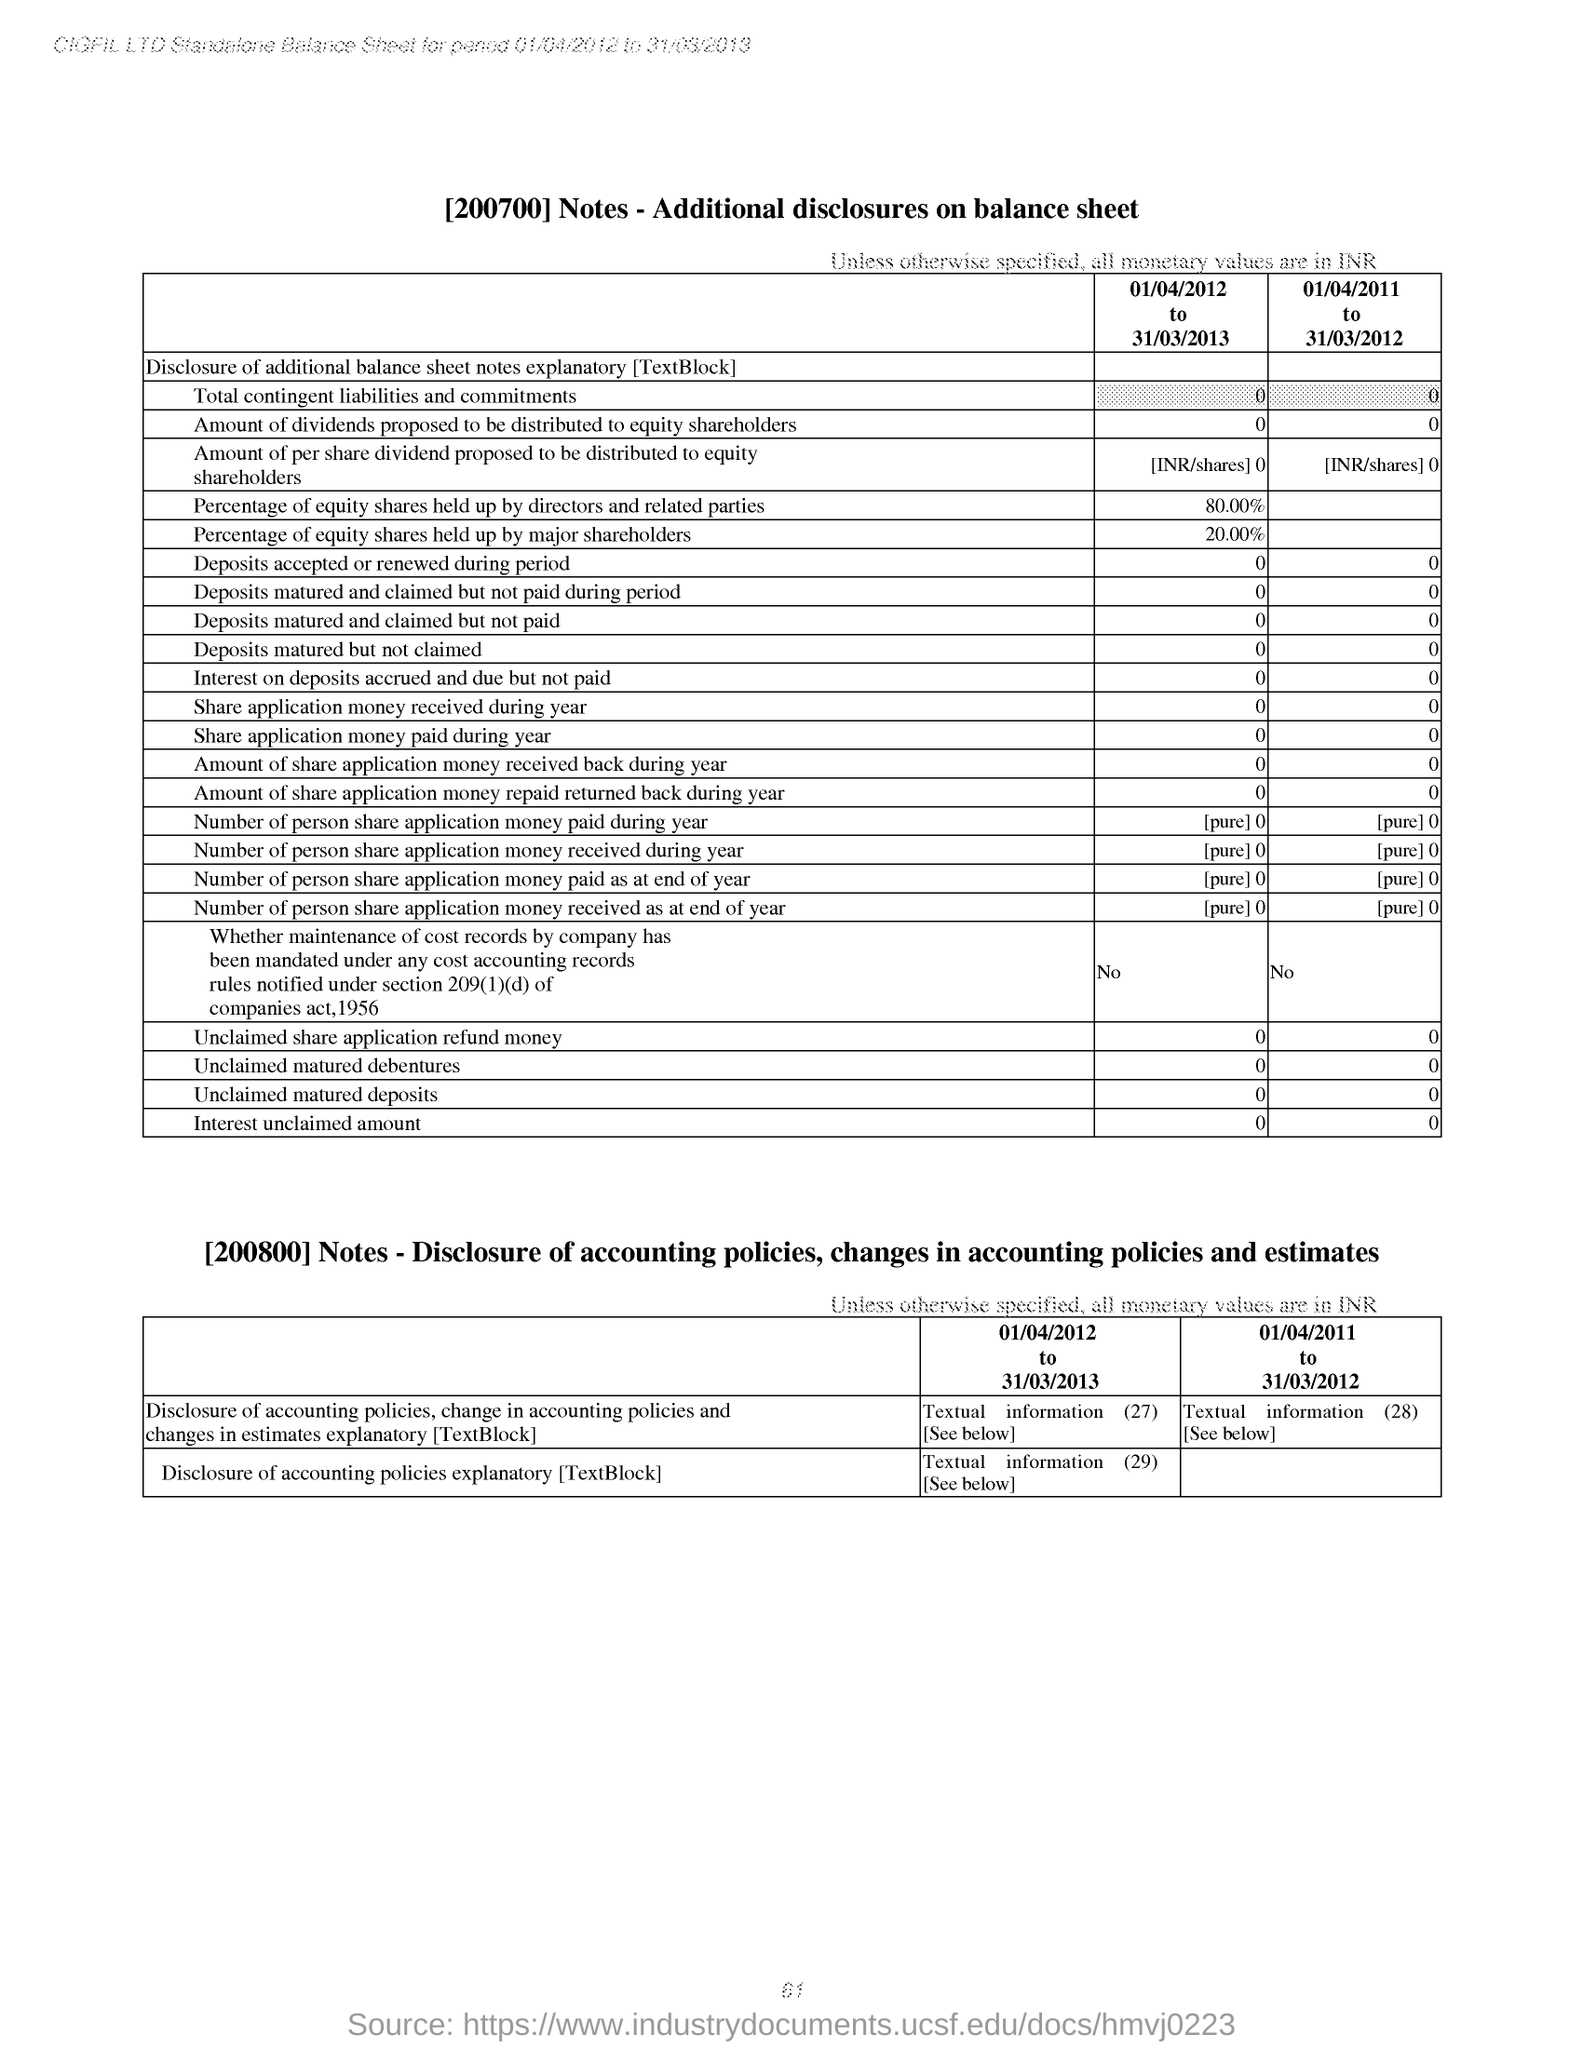Can you provide the trend in percentage of equity shares held by directors and related parties over the two years displayed? For the period from April 1, 2011, to March 31, 2012, directors and related parties held 80.00% of the equity shares. By the next fiscal year ending March 31, 2013, their holding remained the same at 80.00%. This consistent figure suggests stable ownership interest by the directors and related parties across both years. 